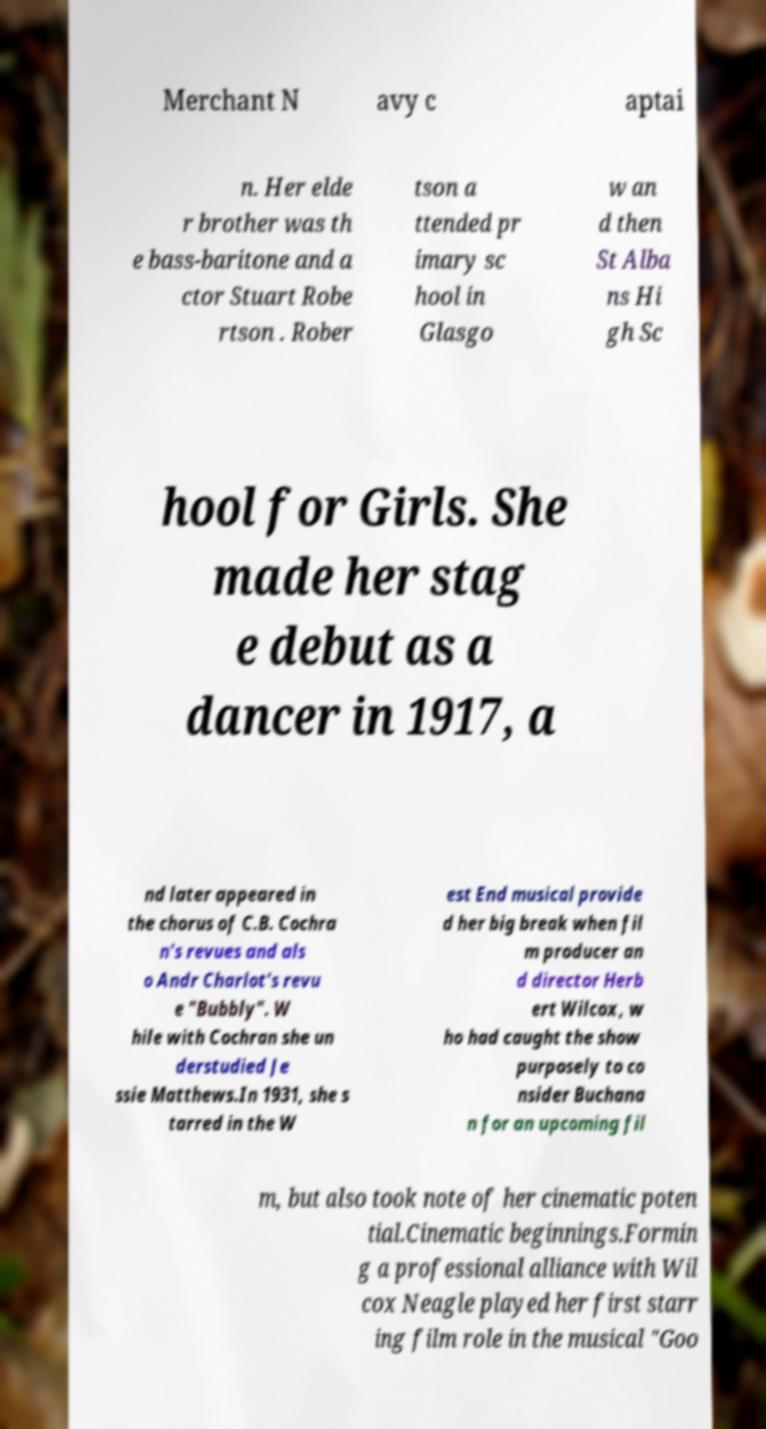Can you accurately transcribe the text from the provided image for me? Merchant N avy c aptai n. Her elde r brother was th e bass-baritone and a ctor Stuart Robe rtson . Rober tson a ttended pr imary sc hool in Glasgo w an d then St Alba ns Hi gh Sc hool for Girls. She made her stag e debut as a dancer in 1917, a nd later appeared in the chorus of C.B. Cochra n's revues and als o Andr Charlot's revu e "Bubbly". W hile with Cochran she un derstudied Je ssie Matthews.In 1931, she s tarred in the W est End musical provide d her big break when fil m producer an d director Herb ert Wilcox, w ho had caught the show purposely to co nsider Buchana n for an upcoming fil m, but also took note of her cinematic poten tial.Cinematic beginnings.Formin g a professional alliance with Wil cox Neagle played her first starr ing film role in the musical "Goo 